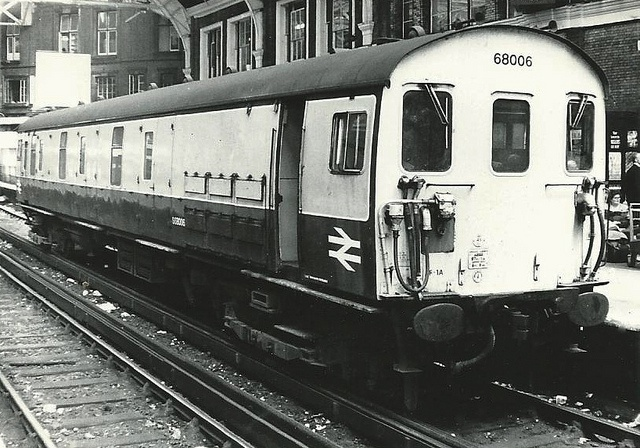Describe the objects in this image and their specific colors. I can see train in ivory, black, gray, and darkgray tones, people in ivory, black, lightgray, gray, and darkgray tones, people in ivory, black, gray, darkgray, and lightgray tones, and people in ivory, darkgray, lightgray, and gray tones in this image. 